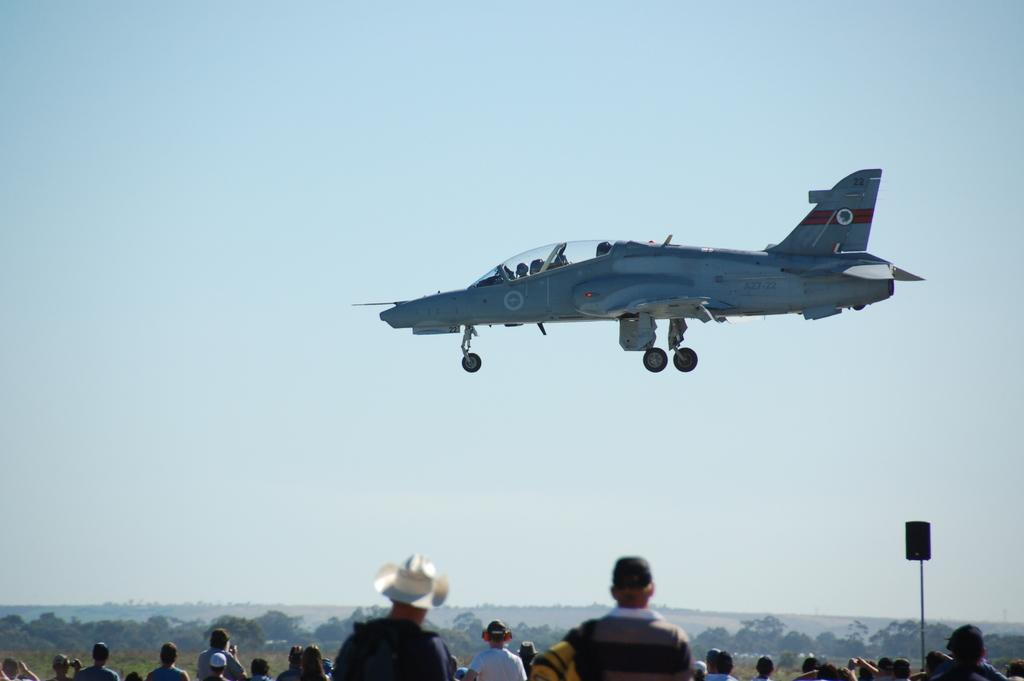What is the main subject in the air in the image? There is a fighter jet in the air in the image. What can be seen at the bottom of the image? There are people at the bottom of the image. What type of natural scenery is visible in the background of the image? There are trees and mountains in the background of the image. What is visible in the sky in the background of the image? The sky is visible in the background of the image. Where is the downtown area in the image? There is no downtown area present in the image. What type of pets can be seen playing in the hall in the image? There are no pets or halls present in the image. 